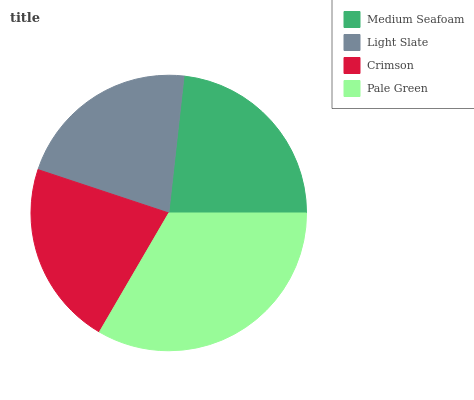Is Light Slate the minimum?
Answer yes or no. Yes. Is Pale Green the maximum?
Answer yes or no. Yes. Is Crimson the minimum?
Answer yes or no. No. Is Crimson the maximum?
Answer yes or no. No. Is Crimson greater than Light Slate?
Answer yes or no. Yes. Is Light Slate less than Crimson?
Answer yes or no. Yes. Is Light Slate greater than Crimson?
Answer yes or no. No. Is Crimson less than Light Slate?
Answer yes or no. No. Is Medium Seafoam the high median?
Answer yes or no. Yes. Is Crimson the low median?
Answer yes or no. Yes. Is Crimson the high median?
Answer yes or no. No. Is Pale Green the low median?
Answer yes or no. No. 